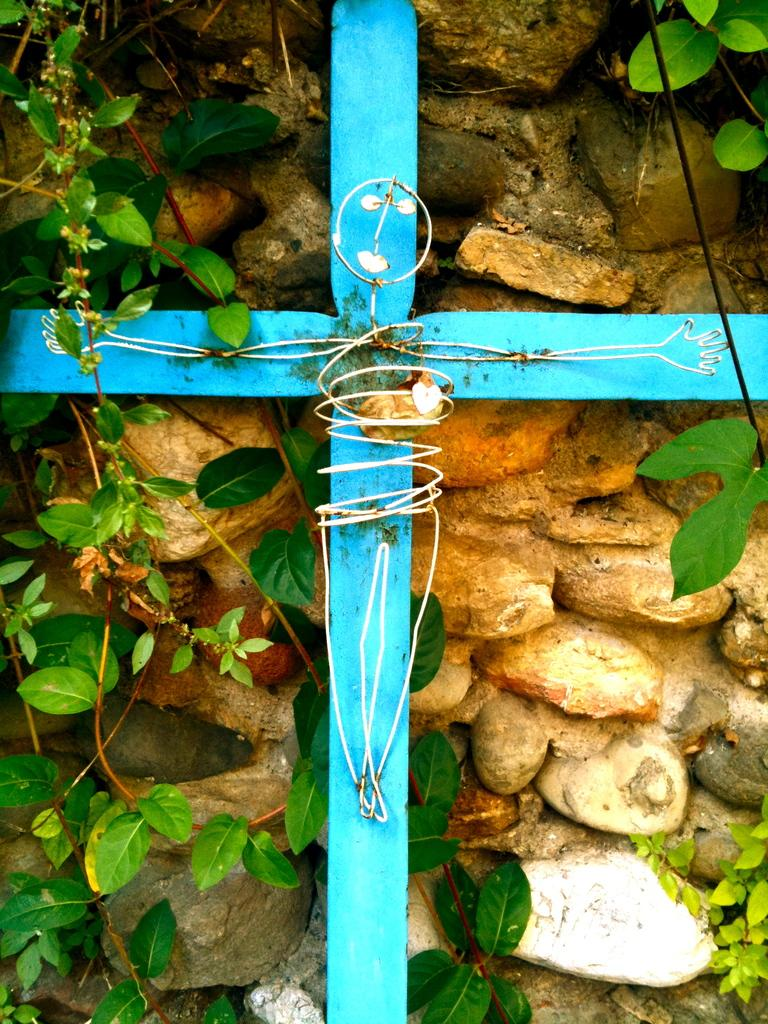What type of natural elements can be seen in the image? There are leaves and stones visible in the image. What is the color of the sticks in the image? The sticks in the image are blue in color. How does the yak interact with the leaves in the image? There is no yak present in the image, so it cannot interact with the leaves. What type of wine is being served with the blue sticks in the image? There is no wine present in the image; it only features leaves, stones, and blue sticks. 